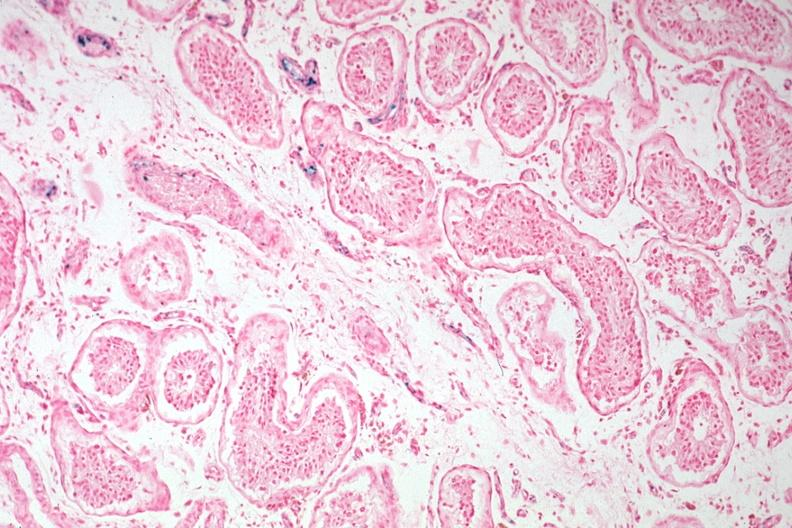what is present?
Answer the question using a single word or phrase. Hemochromatosis 